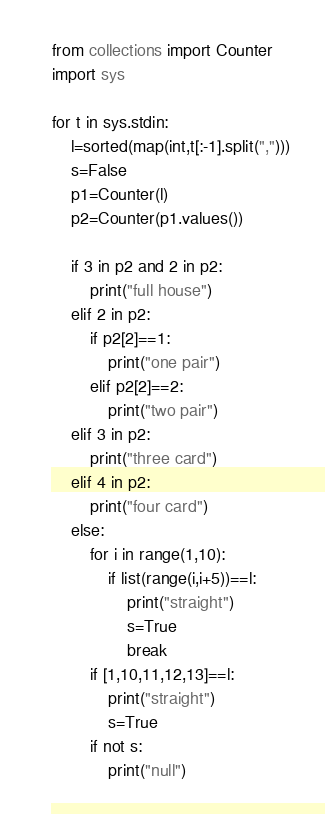Convert code to text. <code><loc_0><loc_0><loc_500><loc_500><_Python_>from collections import Counter
import sys

for t in sys.stdin:
    l=sorted(map(int,t[:-1].split(",")))
    s=False
    p1=Counter(l)
    p2=Counter(p1.values())

    if 3 in p2 and 2 in p2:
        print("full house")
    elif 2 in p2:
        if p2[2]==1:
            print("one pair")
        elif p2[2]==2:
            print("two pair")
    elif 3 in p2:
        print("three card")
    elif 4 in p2:
        print("four card")
    else:
        for i in range(1,10):
            if list(range(i,i+5))==l:
                print("straight")
                s=True
                break
        if [1,10,11,12,13]==l:
            print("straight")
            s=True
        if not s:
            print("null")

</code> 